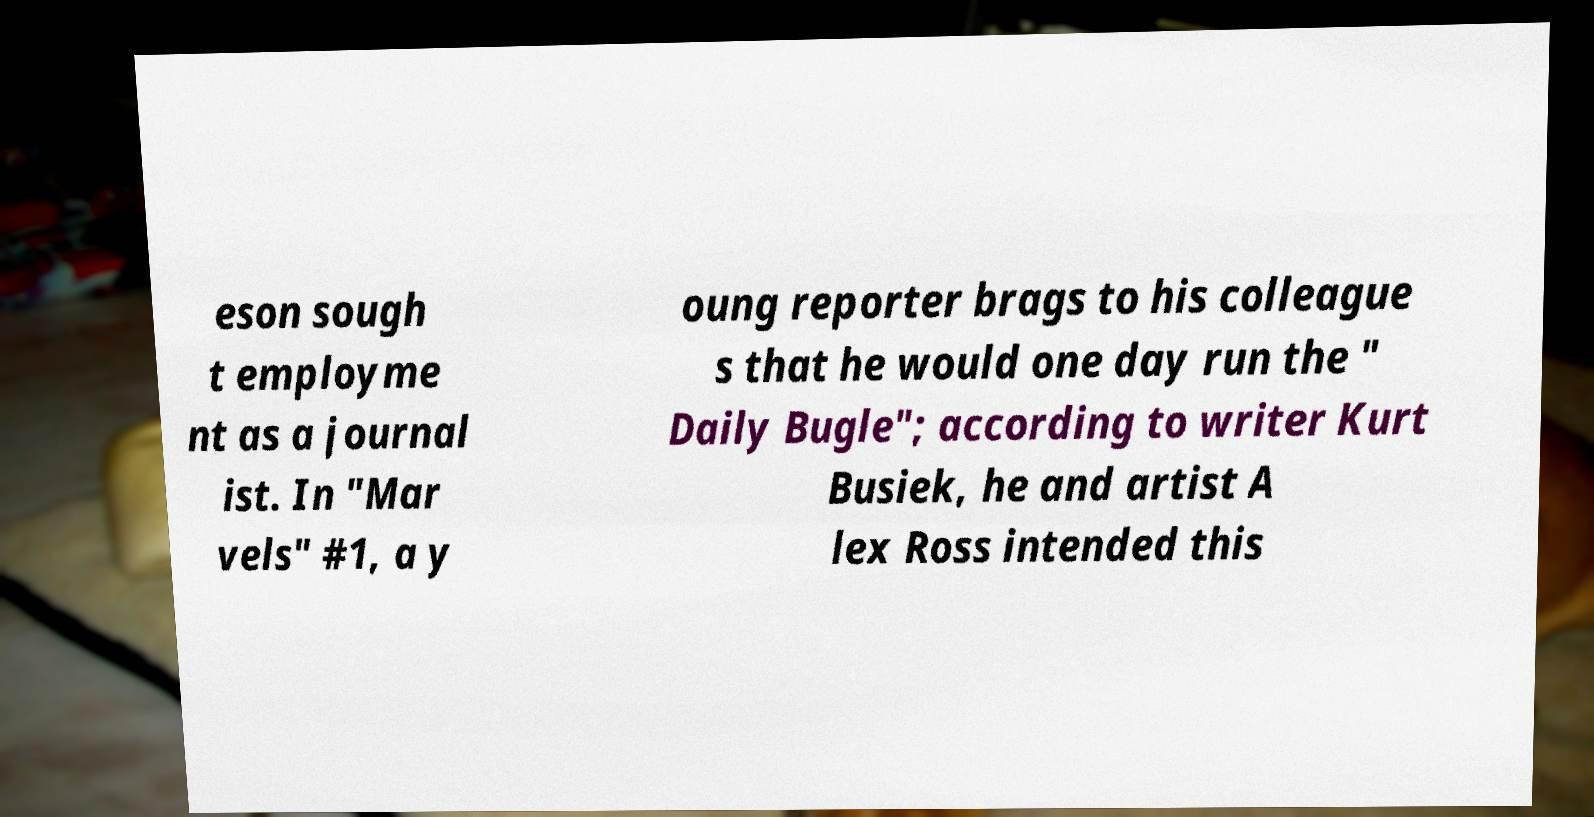Please identify and transcribe the text found in this image. eson sough t employme nt as a journal ist. In "Mar vels" #1, a y oung reporter brags to his colleague s that he would one day run the " Daily Bugle"; according to writer Kurt Busiek, he and artist A lex Ross intended this 